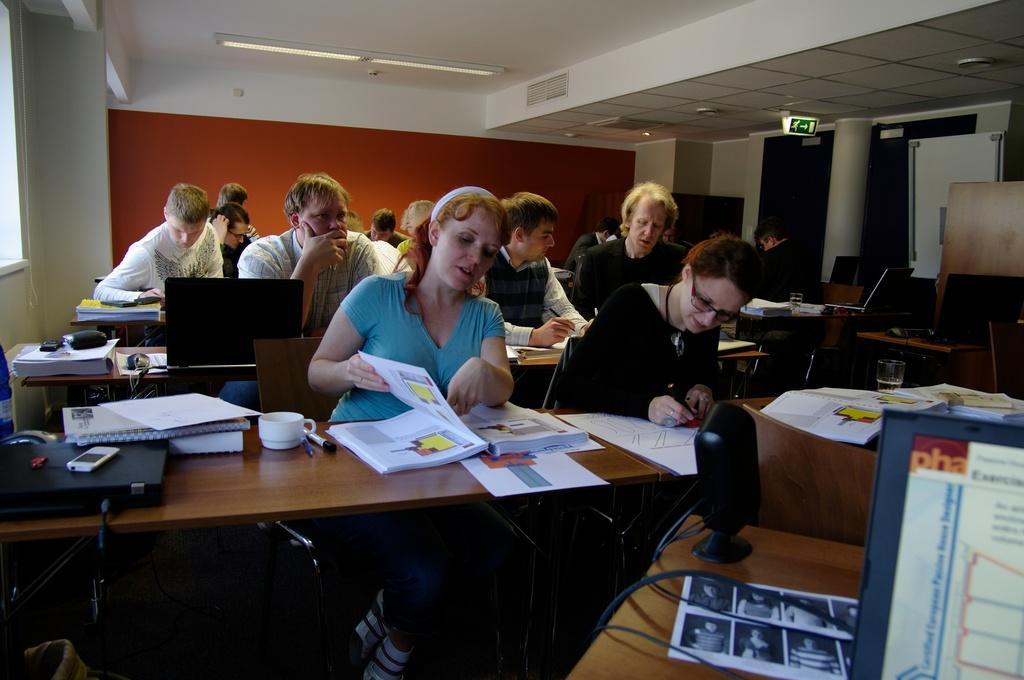Can you describe this image briefly? There are group of people sitting on the chairs. This is a table. There is a cup,laptop,mobile phone,books, and some other objects placed on the table. This is a ceiling light which is on the roof top. This is a sign board which shows the directions. This is a pillar. I can see a tumbler placed on the table. 